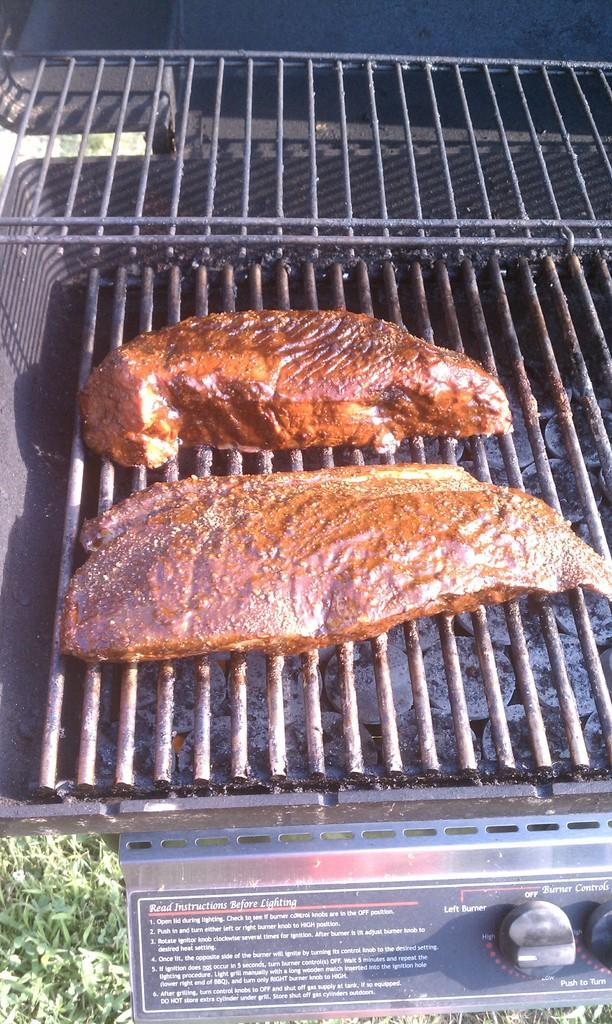<image>
Share a concise interpretation of the image provided. Read the instructions before lighting this grill with two pieces of meat on it. 